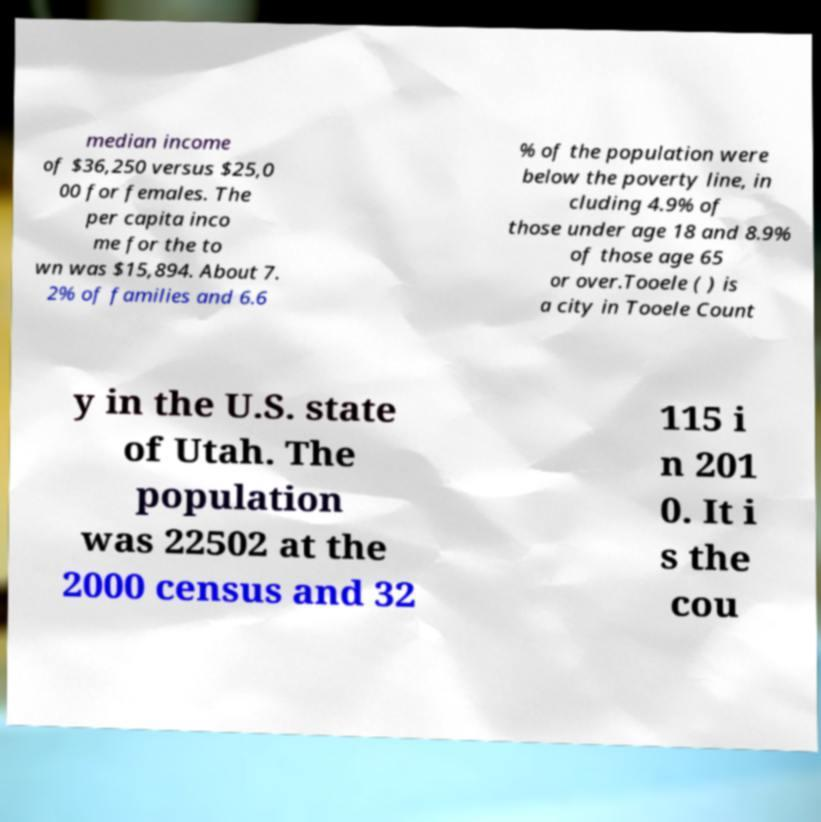Can you read and provide the text displayed in the image?This photo seems to have some interesting text. Can you extract and type it out for me? median income of $36,250 versus $25,0 00 for females. The per capita inco me for the to wn was $15,894. About 7. 2% of families and 6.6 % of the population were below the poverty line, in cluding 4.9% of those under age 18 and 8.9% of those age 65 or over.Tooele ( ) is a city in Tooele Count y in the U.S. state of Utah. The population was 22502 at the 2000 census and 32 115 i n 201 0. It i s the cou 